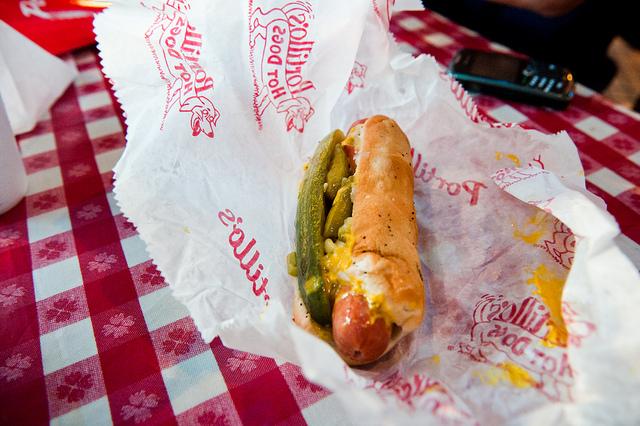Is there avocado slices on this hot dog??
Give a very brief answer. No. Is this messy?
Quick response, please. Yes. What color is the cell phone?
Quick response, please. Black. 